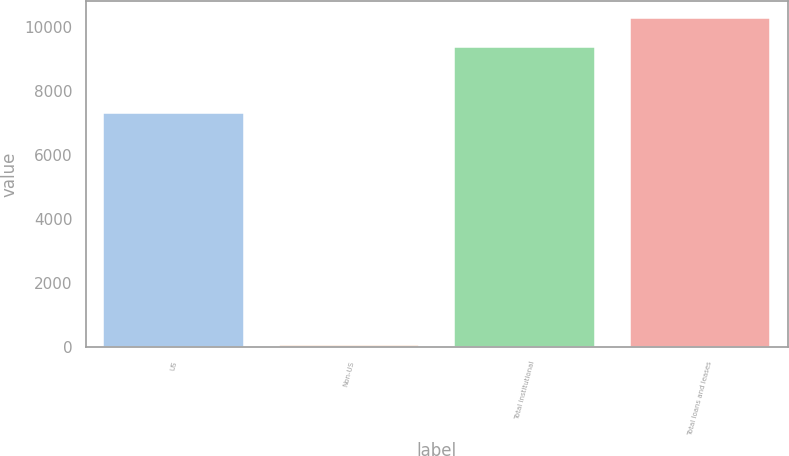Convert chart. <chart><loc_0><loc_0><loc_500><loc_500><bar_chart><fcel>US<fcel>Non-US<fcel>Total institutional<fcel>Total loans and leases<nl><fcel>7313<fcel>77<fcel>9377<fcel>10307<nl></chart> 